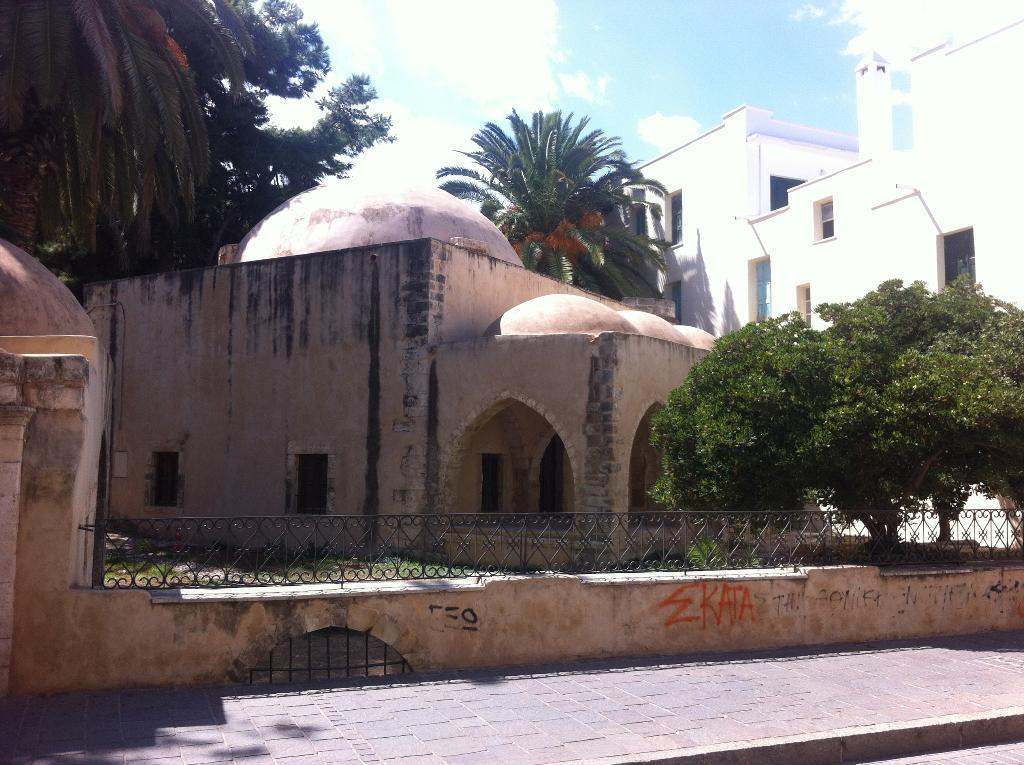What type of path is visible in the image? There is a footpath in the image. What can be seen alongside the footpath? There is a fence in the image. What type of vegetation is present in the image? There are trees and grass in the image. What type of structures are visible in the image? There are buildings with windows and walls in the image. What is visible in the background of the image? The sky with clouds is visible in the background of the image. What type of sleet is falling from the sky in the image? There is no sleet present in the image; the sky is visible with clouds. What type of war is being depicted in the image? There is no war depicted in the image; it features a footpath, fence, trees, grass, buildings, walls, and sky. 